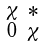Convert formula to latex. <formula><loc_0><loc_0><loc_500><loc_500>\begin{smallmatrix} \chi & \ast \\ 0 & \chi \end{smallmatrix}</formula> 